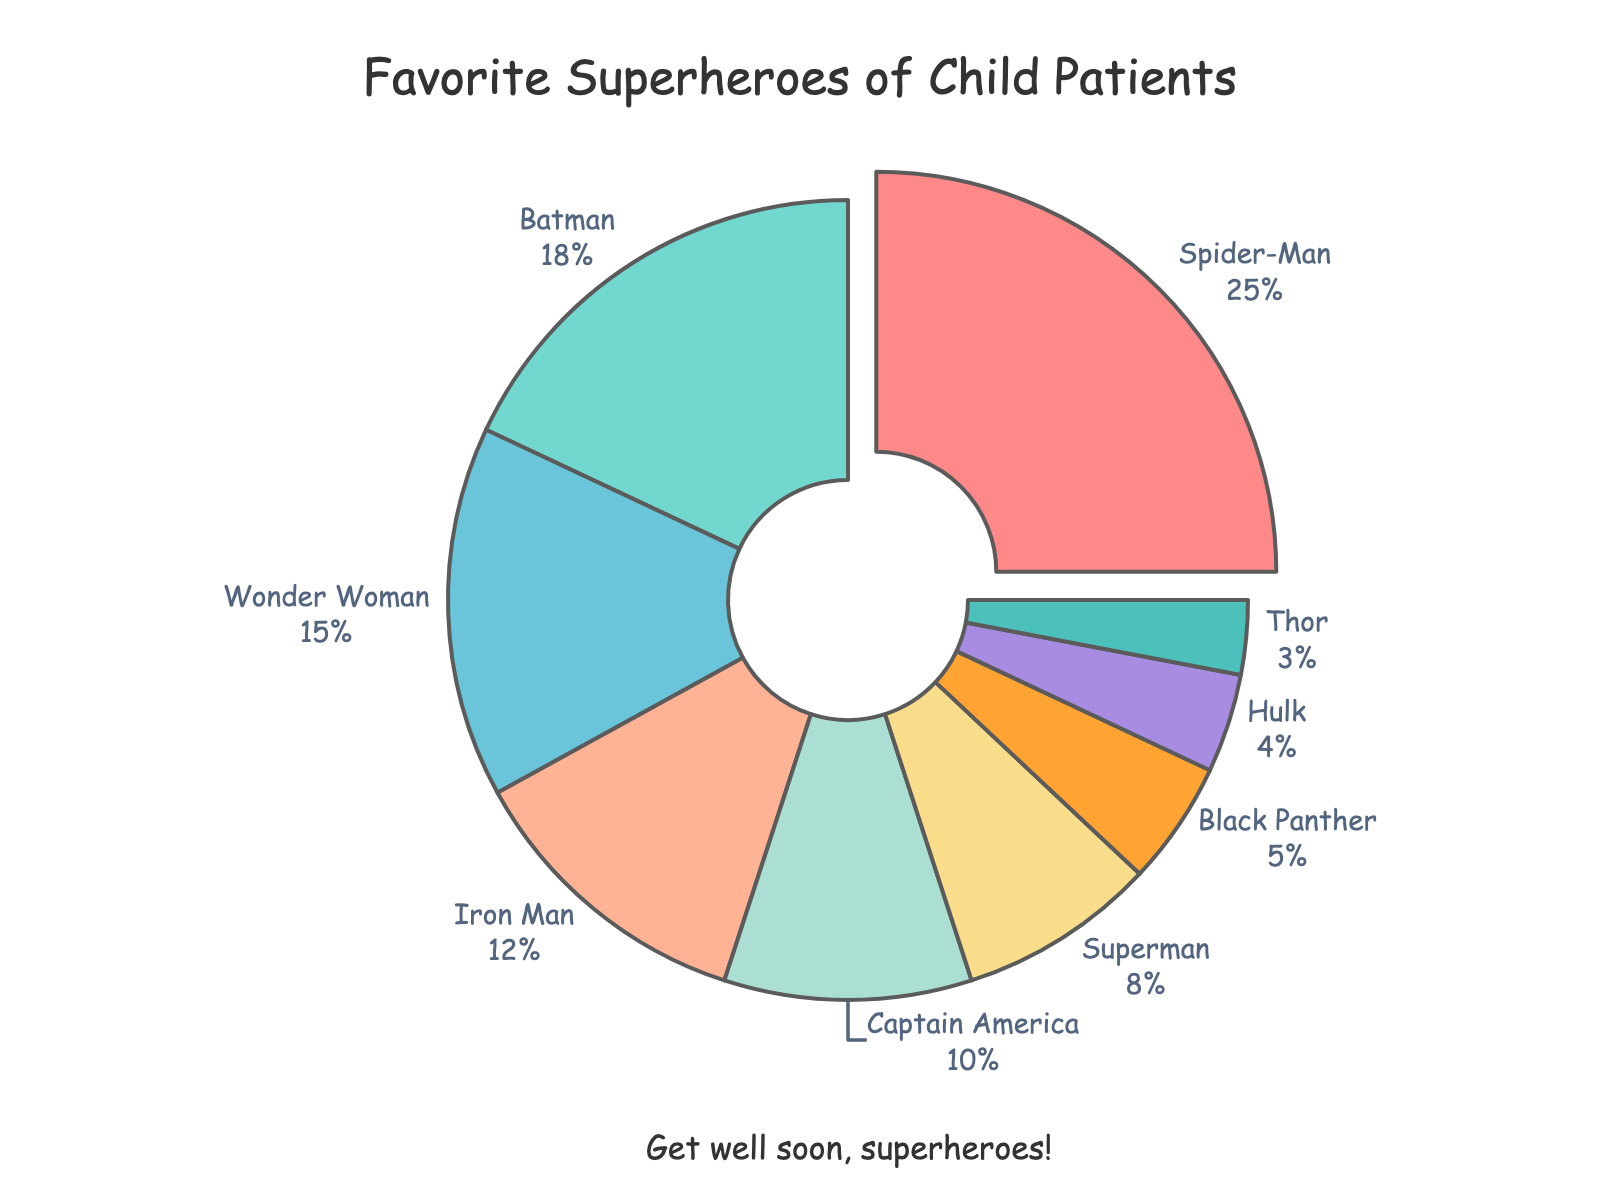Who is the most popular superhero among child patients? Look at the segment with the largest percentage. The biggest segment corresponds to Spider-Man with 25%.
Answer: Spider-Man Which superhero characters are liked by at least 10% of child patients? Review the percentages listed for each character and pick those with 10% or higher: Spider-Man (25%), Batman (18%), Wonder Woman (15%), Iron Man (12%), Captain America (10%).
Answer: Spider-Man, Batman, Wonder Woman, Iron Man, Captain America Which character is less popular: Superman or Iron Man? Compare the percentages for each character: Iron Man has 12% whereas Superman has 8%.
Answer: Superman What's the combined percentage of child patients who prefer Hulk and Thor together? Add the percentages for Hulk and Thor: 4% (Hulk) + 3% (Thor) = 7%.
Answer: 7% How much more popular is Spider-Man than Black Panther? Subtract Black Panther’s percentage from Spider-Man’s: 25% (Spider-Man) - 5% (Black Panther) = 20%.
Answer: 20% If you sum up the percentages of Batman and Captain America, do they together surpass Spider-Man's percentage? Add Batman’s and Captain America's percentages: 18% (Batman) + 10% (Captain America) = 28%. Compare it with Spider-Man's 25%.
Answer: Yes Which character takes up a green segment in the pie chart? Visually identify the green segment in the pie chart, which corresponds to Batman as per the color scheme given (#4ECDC4).
Answer: Batman What fraction of the children like Wonder Woman, expressed as a percentage of those who like Wonder Woman plus Captain America? Calculate the fraction as: (Wonder Woman's percentage / (Wonder Woman's percentage + Captain America's percentage)) * 100%. That's (15 / (15 + 10)) * 100% = 60%.
Answer: 60% Who is the least popular superhero character among the child patients, and what is their percentage? Identify the character with the smallest segment in the pie chart which is Thor with 3%.
Answer: Thor How many superheroes have a popularity of less than 10%? Look at the data and count the characters with percentages less than 10%: Superman (8%), Black Panther (5%), Hulk (4%), Thor (3%).
Answer: 4 